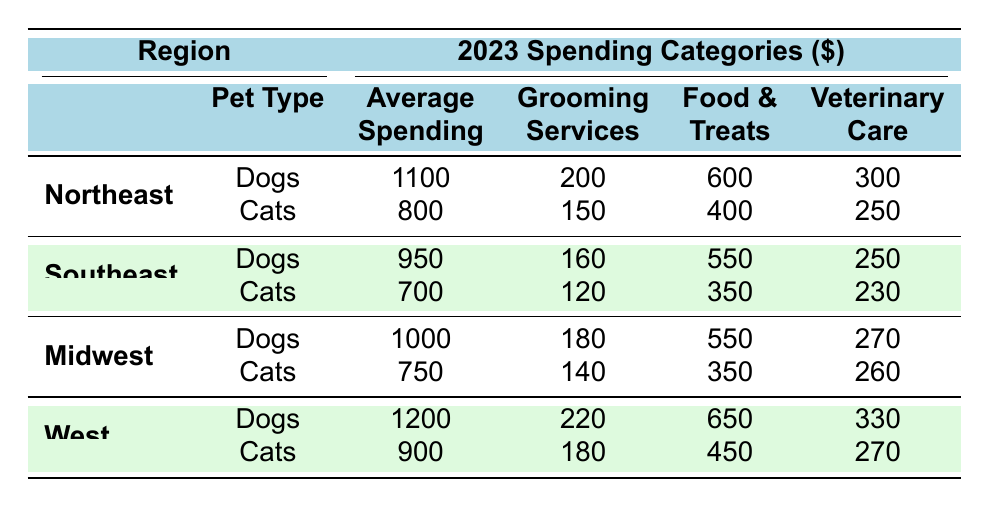What is the average spending on dogs in the Northeast region? According to the table, the average spending on dogs in the Northeast region is listed as 1100 dollars.
Answer: 1100 Which region has the highest average spending on cats? The West region has an average spending of 900 dollars on cats, which is higher than the other regions (Northeast: 800, Southeast: 700, Midwest: 750).
Answer: West What is the total spending on grooming services for dogs in all regions? The grooming services spending for dogs in each region is as follows: Northeast: 200, Southeast: 160, Midwest: 180, West: 220. Adding these amounts gives 200 + 160 + 180 + 220 = 760 dollars total.
Answer: 760 Is the average spending on dogs in the Southeast higher than that in the Midwest? The average spending on dogs in the Southeast is 950 dollars, while in the Midwest it is 1000 dollars. Since 950 is less than 1000, the statement is false.
Answer: No What is the difference in average spending on cats between the Northeast and the Southeast? The average spending on cats in the Northeast is 800 dollars and in the Southeast is 700 dollars. The difference is 800 - 700 = 100 dollars.
Answer: 100 Which pet type has the highest veterinary care spending in the West region? For the West region, dogs have 330 dollars in veterinary care spending, while cats have 270 dollars. Since 330 is greater than 270, dogs have the highest spending in this category.
Answer: Dogs What is the average total spending on pets (dogs and cats) in the Midwest region? In the Midwest, the average spending is 1000 (dogs) + 750 (cats) = 1750 dollars total. To find the average, divide by 2 (the number of pet types), which gives 1750 / 2 = 875 dollars.
Answer: 875 In which region is the spending on food and treats for dogs the lowest? The food and treats spending for dogs is as follows: Northeast: 600, Southeast: 550, Midwest: 550, West: 650. The lowest spending is in the Southeast and Midwest where it is 550 dollars.
Answer: Southeast and Midwest How much more is spent on veterinary care for dogs in the West compared to the Northeast? In the West, the veterinary care spending for dogs is 330 dollars, and in the Northeast, it is 300 dollars. The difference is 330 - 300 = 30 dollars.
Answer: 30 Is the average spending on grooming services for cats in the Northeast more than in the Midwest? The average spending on grooming services for cats is 150 dollars in the Northeast and 140 dollars in the Midwest. Since 150 is greater than 140, the statement is true.
Answer: Yes 